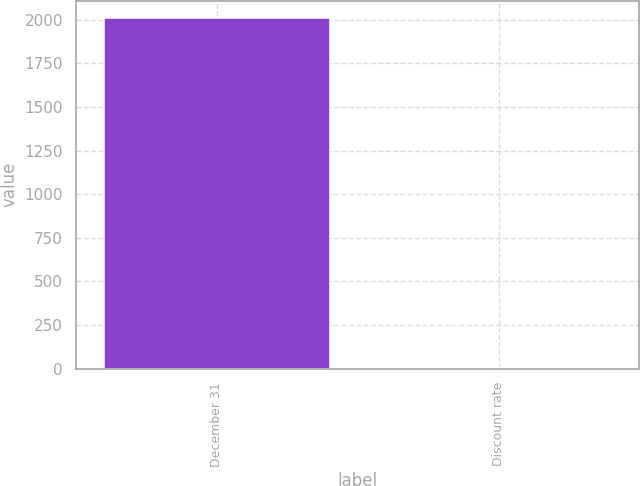<chart> <loc_0><loc_0><loc_500><loc_500><bar_chart><fcel>December 31<fcel>Discount rate<nl><fcel>2008<fcel>6.3<nl></chart> 